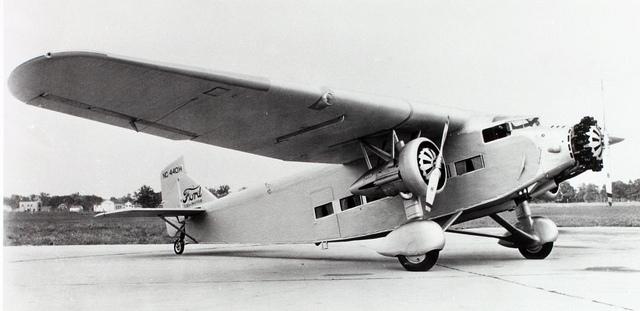Is this a modern plane?
Keep it brief. No. How many people can fit in this plane?
Give a very brief answer. 10. What sort of plane is this?
Quick response, please. Propeller. 